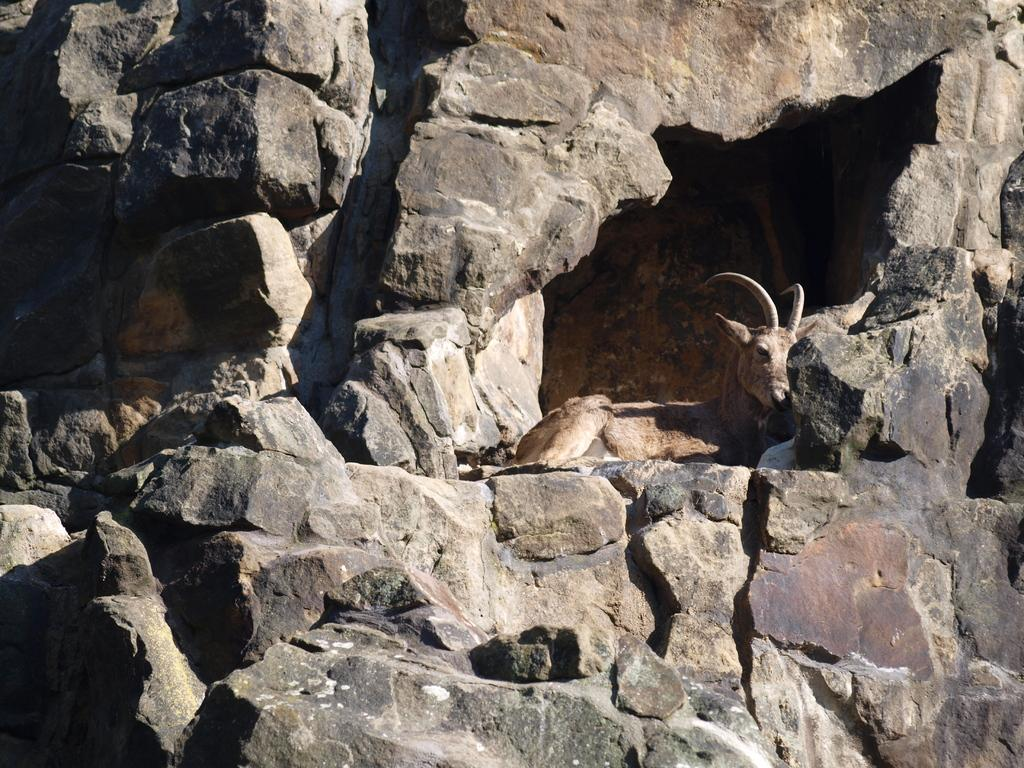What type of natural formation can be seen in the image? There are rocks in the image. How are the rocks positioned in the image? The rocks are over a place, possibly a landscape or terrain. What animal is present in the image? There is a deer in the image. Where is the deer located in relation to the rocks? The deer is sitting near a rock cave. What type of truck can be seen in the image? There is no truck present in the image; it features rocks, a deer, and a rock cave. Is there any indication that the deer is cooking in the image? There is no indication that the deer is cooking or performing any culinary activities in the image. 